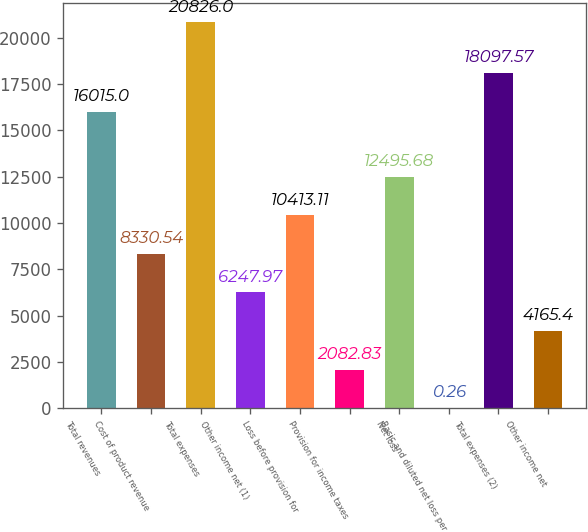Convert chart to OTSL. <chart><loc_0><loc_0><loc_500><loc_500><bar_chart><fcel>Total revenues<fcel>Cost of product revenue<fcel>Total expenses<fcel>Other income net (1)<fcel>Loss before provision for<fcel>Provision for income taxes<fcel>Net loss<fcel>Basic and diluted net loss per<fcel>Total expenses (2)<fcel>Other income net<nl><fcel>16015<fcel>8330.54<fcel>20826<fcel>6247.97<fcel>10413.1<fcel>2082.83<fcel>12495.7<fcel>0.26<fcel>18097.6<fcel>4165.4<nl></chart> 